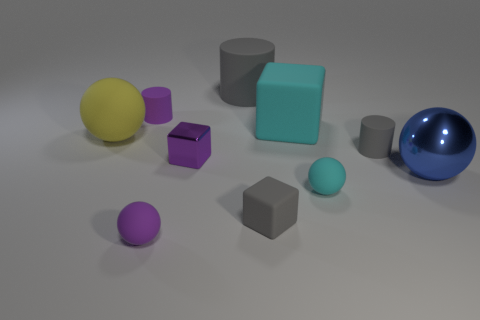What size is the cylinder that is the same color as the shiny cube?
Provide a short and direct response. Small. Are there more tiny gray matte objects that are right of the gray matte cube than large red blocks?
Ensure brevity in your answer.  Yes. Are there any balls that have the same color as the tiny metal block?
Your answer should be compact. Yes. What color is the other sphere that is the same size as the cyan rubber sphere?
Make the answer very short. Purple. How many metal things are to the left of the blue thing in front of the big cyan object?
Provide a short and direct response. 1. What number of objects are big yellow rubber things that are behind the purple ball or large blue shiny spheres?
Your answer should be compact. 2. How many tiny gray objects are made of the same material as the large gray cylinder?
Your answer should be compact. 2. What shape is the large matte object that is the same color as the small rubber cube?
Your answer should be compact. Cylinder. Are there an equal number of cyan rubber spheres that are in front of the small cyan sphere and brown rubber cylinders?
Offer a very short reply. Yes. There is a matte cylinder that is to the left of the large gray object; what is its size?
Ensure brevity in your answer.  Small. 